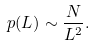Convert formula to latex. <formula><loc_0><loc_0><loc_500><loc_500>p ( L ) \sim \frac { N } { L ^ { 2 } } .</formula> 